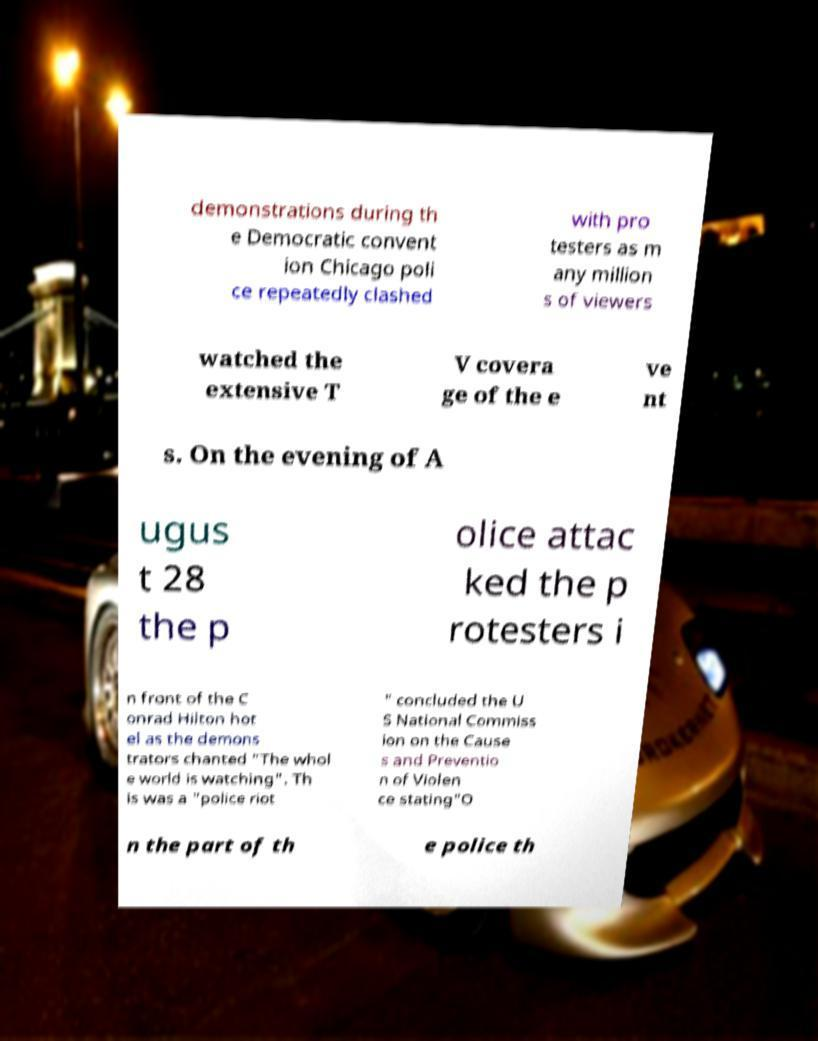There's text embedded in this image that I need extracted. Can you transcribe it verbatim? demonstrations during th e Democratic convent ion Chicago poli ce repeatedly clashed with pro testers as m any million s of viewers watched the extensive T V covera ge of the e ve nt s. On the evening of A ugus t 28 the p olice attac ked the p rotesters i n front of the C onrad Hilton hot el as the demons trators chanted "The whol e world is watching". Th is was a "police riot " concluded the U S National Commiss ion on the Cause s and Preventio n of Violen ce stating"O n the part of th e police th 